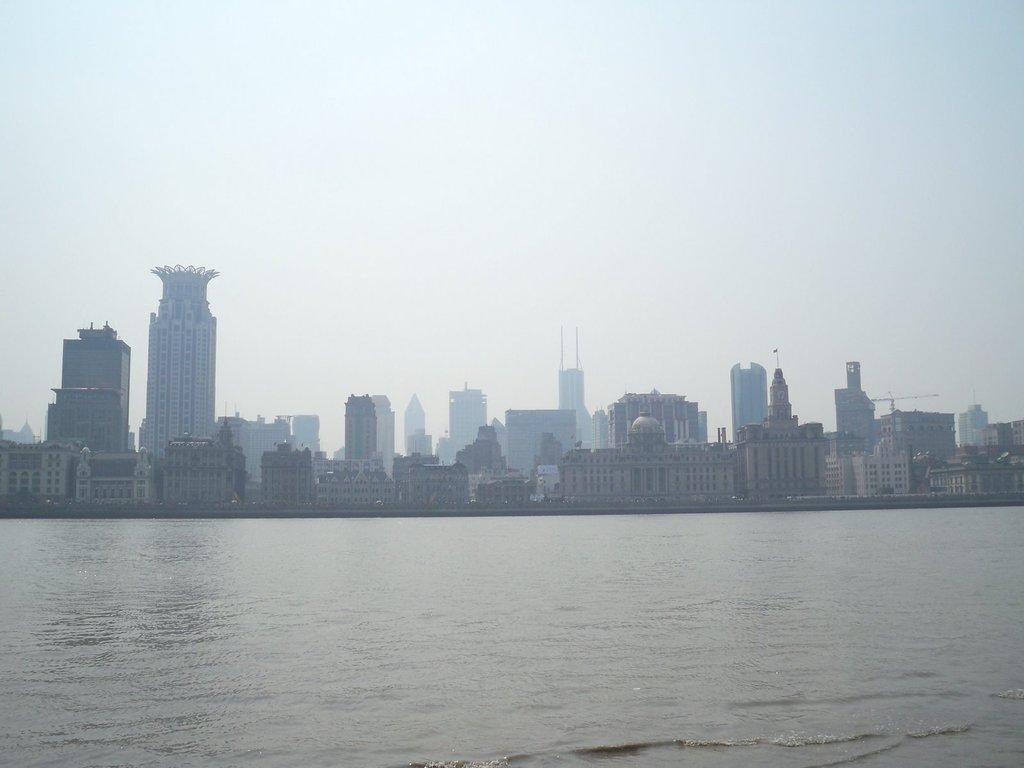What is visible in the image? There is water visible in the image. What can be seen in the distance in the image? There are buildings in the background of the image. How would you describe the color of the sky in the image? The sky is a combination of white and blue colors. What type of food is being prepared in the image? There is no food preparation visible in the image; it primarily features water and buildings in the background. 